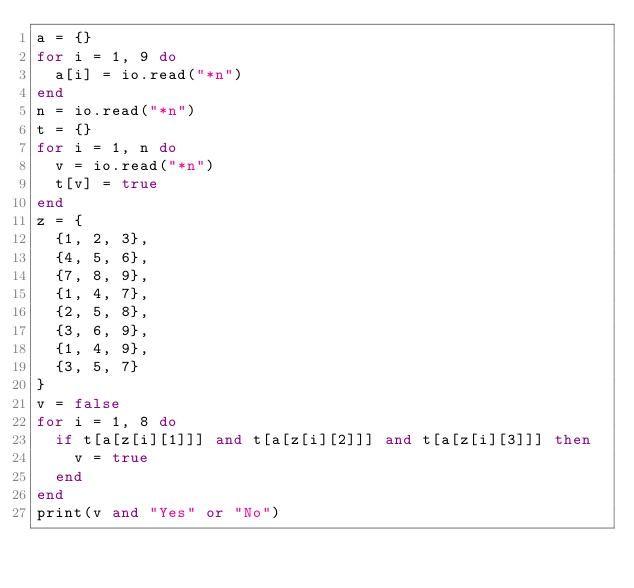Convert code to text. <code><loc_0><loc_0><loc_500><loc_500><_Lua_>a = {}
for i = 1, 9 do
  a[i] = io.read("*n")
end
n = io.read("*n")
t = {}
for i = 1, n do
  v = io.read("*n")
  t[v] = true
end
z = {
  {1, 2, 3},
  {4, 5, 6},
  {7, 8, 9},
  {1, 4, 7},
  {2, 5, 8},
  {3, 6, 9},
  {1, 4, 9},
  {3, 5, 7}
}
v = false
for i = 1, 8 do
  if t[a[z[i][1]]] and t[a[z[i][2]]] and t[a[z[i][3]]] then
    v = true
  end
end
print(v and "Yes" or "No")
</code> 